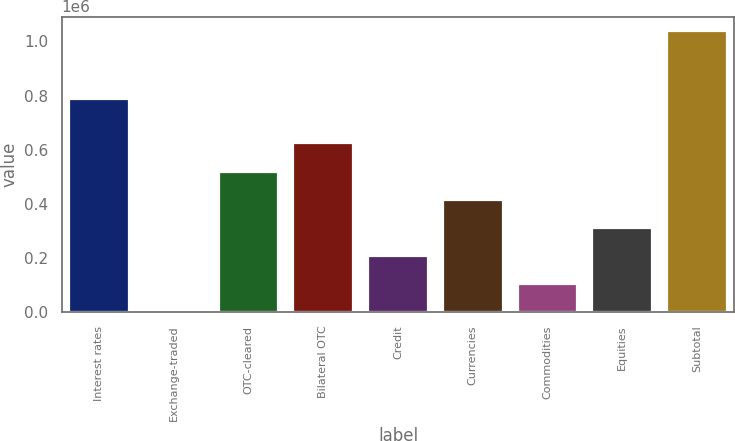<chart> <loc_0><loc_0><loc_500><loc_500><bar_chart><fcel>Interest rates<fcel>Exchange-traded<fcel>OTC-cleared<fcel>Bilateral OTC<fcel>Credit<fcel>Currencies<fcel>Commodities<fcel>Equities<fcel>Subtotal<nl><fcel>786362<fcel>228<fcel>519638<fcel>623519<fcel>207992<fcel>415756<fcel>104110<fcel>311874<fcel>1.03905e+06<nl></chart> 